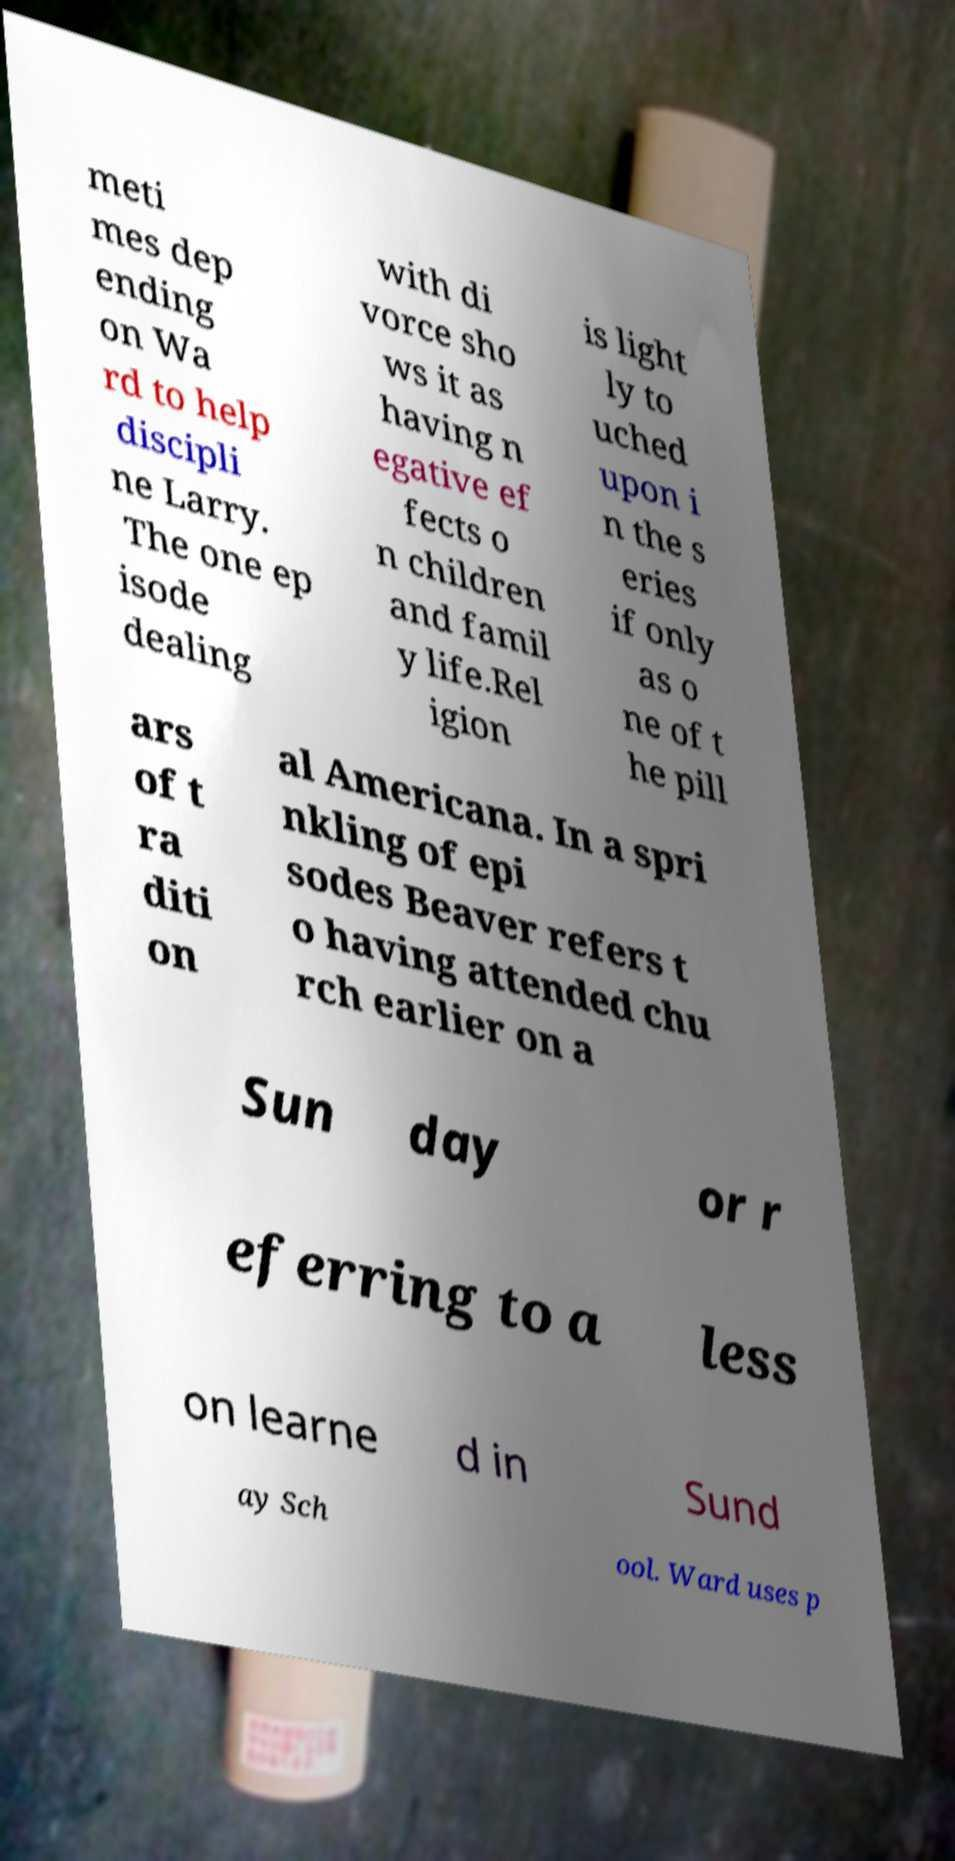Can you accurately transcribe the text from the provided image for me? meti mes dep ending on Wa rd to help discipli ne Larry. The one ep isode dealing with di vorce sho ws it as having n egative ef fects o n children and famil y life.Rel igion is light ly to uched upon i n the s eries if only as o ne of t he pill ars of t ra diti on al Americana. In a spri nkling of epi sodes Beaver refers t o having attended chu rch earlier on a Sun day or r eferring to a less on learne d in Sund ay Sch ool. Ward uses p 